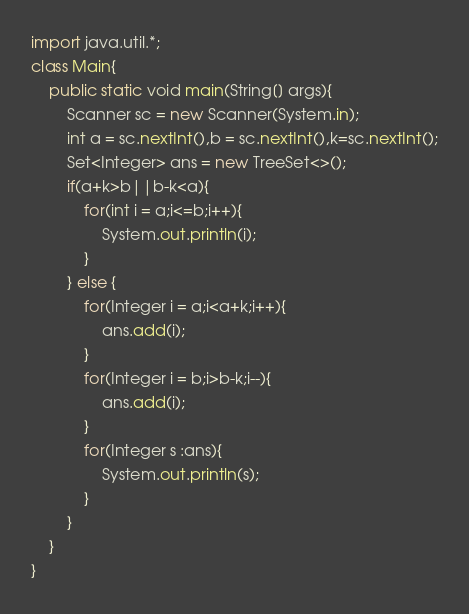Convert code to text. <code><loc_0><loc_0><loc_500><loc_500><_Java_>import java.util.*;
class Main{
    public static void main(String[] args){
        Scanner sc = new Scanner(System.in);
        int a = sc.nextInt(),b = sc.nextInt(),k=sc.nextInt();
        Set<Integer> ans = new TreeSet<>();
        if(a+k>b||b-k<a){
            for(int i = a;i<=b;i++){
                System.out.println(i);
            }
        } else {
            for(Integer i = a;i<a+k;i++){
                ans.add(i);
            }
            for(Integer i = b;i>b-k;i--){
                ans.add(i);
            }
            for(Integer s :ans){
                System.out.println(s);
            }
        }
    }
}</code> 